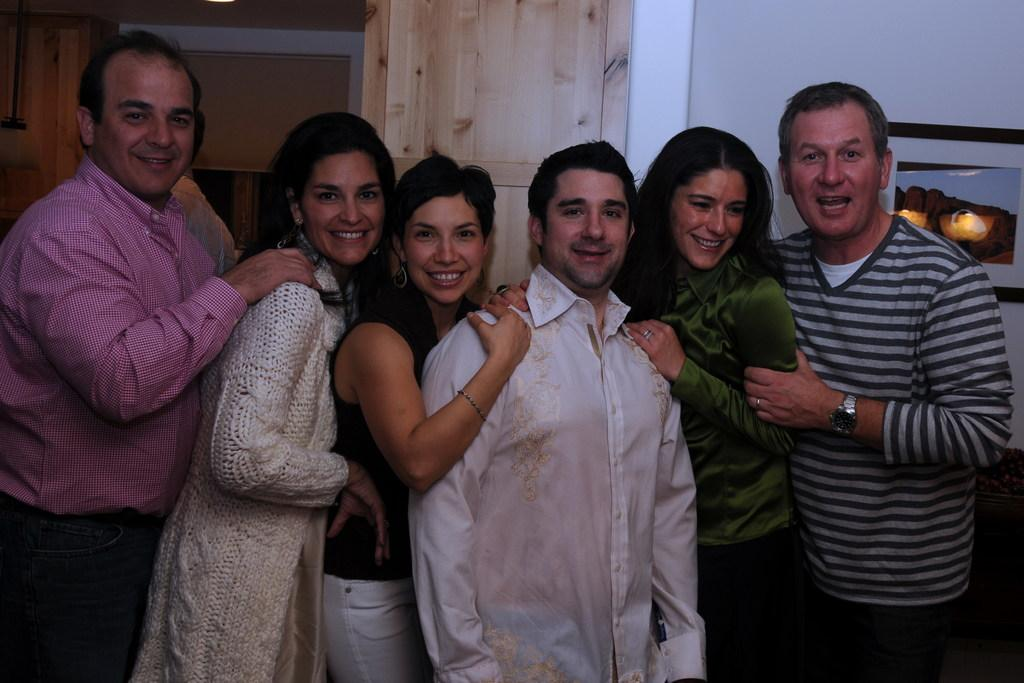What is the main subject of the image? The main subject of the image is a group of people. What are the people in the image doing? The people are standing and smiling. What can be seen on the wall in the background? There is a photo frame on the wall in the background. What type of doors are visible in the background? There are wooden doors in the background. What is the background of the image composed of? The background of the image includes a wall. What type of hammer is being used by the person in the image? There is no hammer present in the image; the people are simply standing and smiling. 